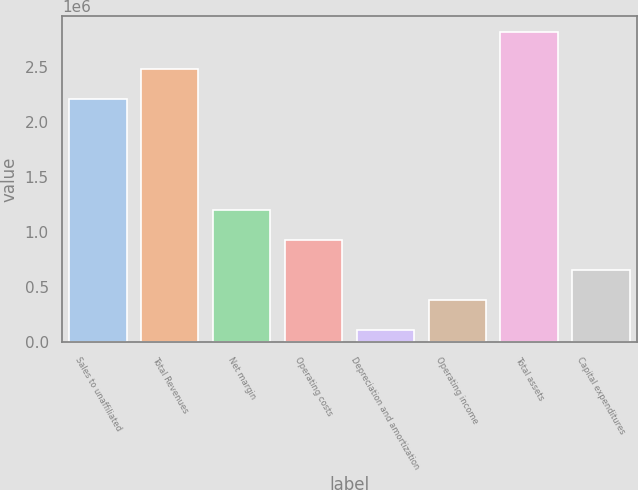<chart> <loc_0><loc_0><loc_500><loc_500><bar_chart><fcel>Sales to unaffiliated<fcel>Total Revenues<fcel>Net margin<fcel>Operating costs<fcel>Depreciation and amortization<fcel>Operating income<fcel>Total assets<fcel>Capital expenditures<nl><fcel>2.21621e+06<fcel>2.48732e+06<fcel>1.19787e+06<fcel>926763<fcel>113437<fcel>384546<fcel>2.82452e+06<fcel>655654<nl></chart> 